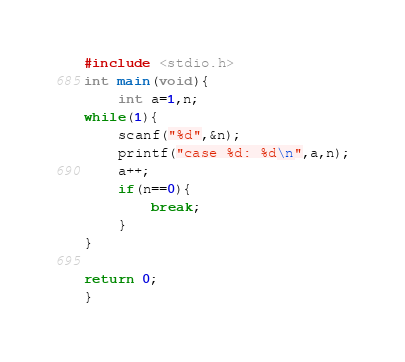<code> <loc_0><loc_0><loc_500><loc_500><_C_>#include <stdio.h>
int main(void){
    int a=1,n;
while(1){
    scanf("%d",&n);
    printf("case %d: %d\n",a,n);
    a++;
    if(n==0){
        break;
    }
}

return 0;
}</code> 